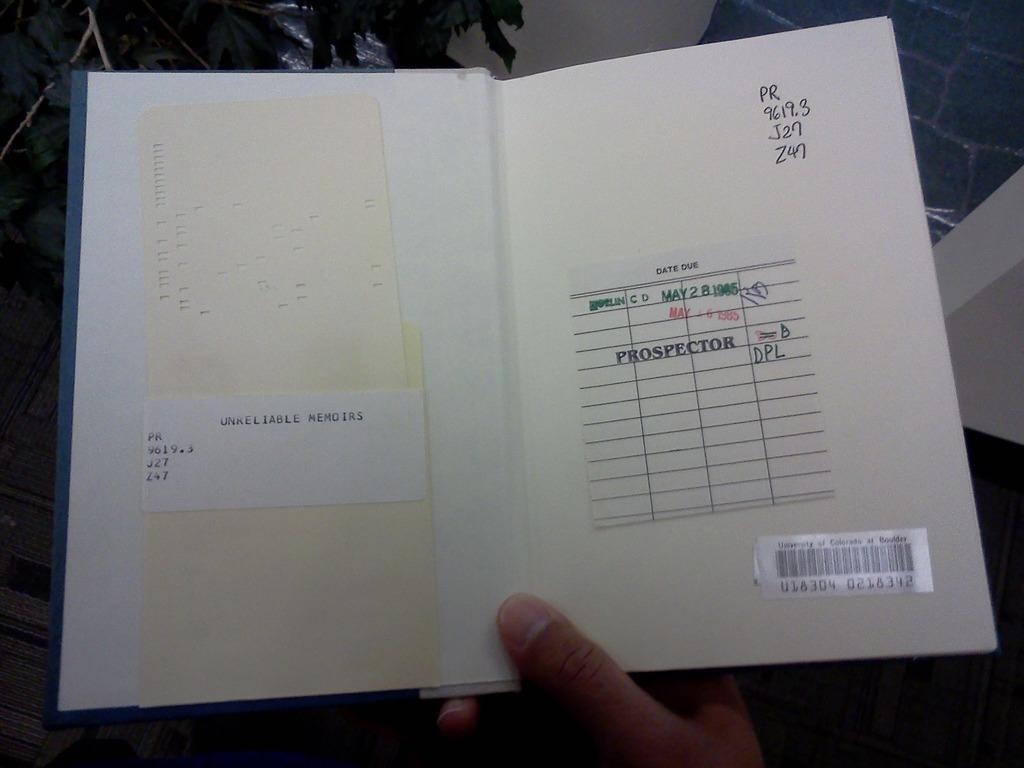<image>
Share a concise interpretation of the image provided. A book is opened to show a date due list inside. 